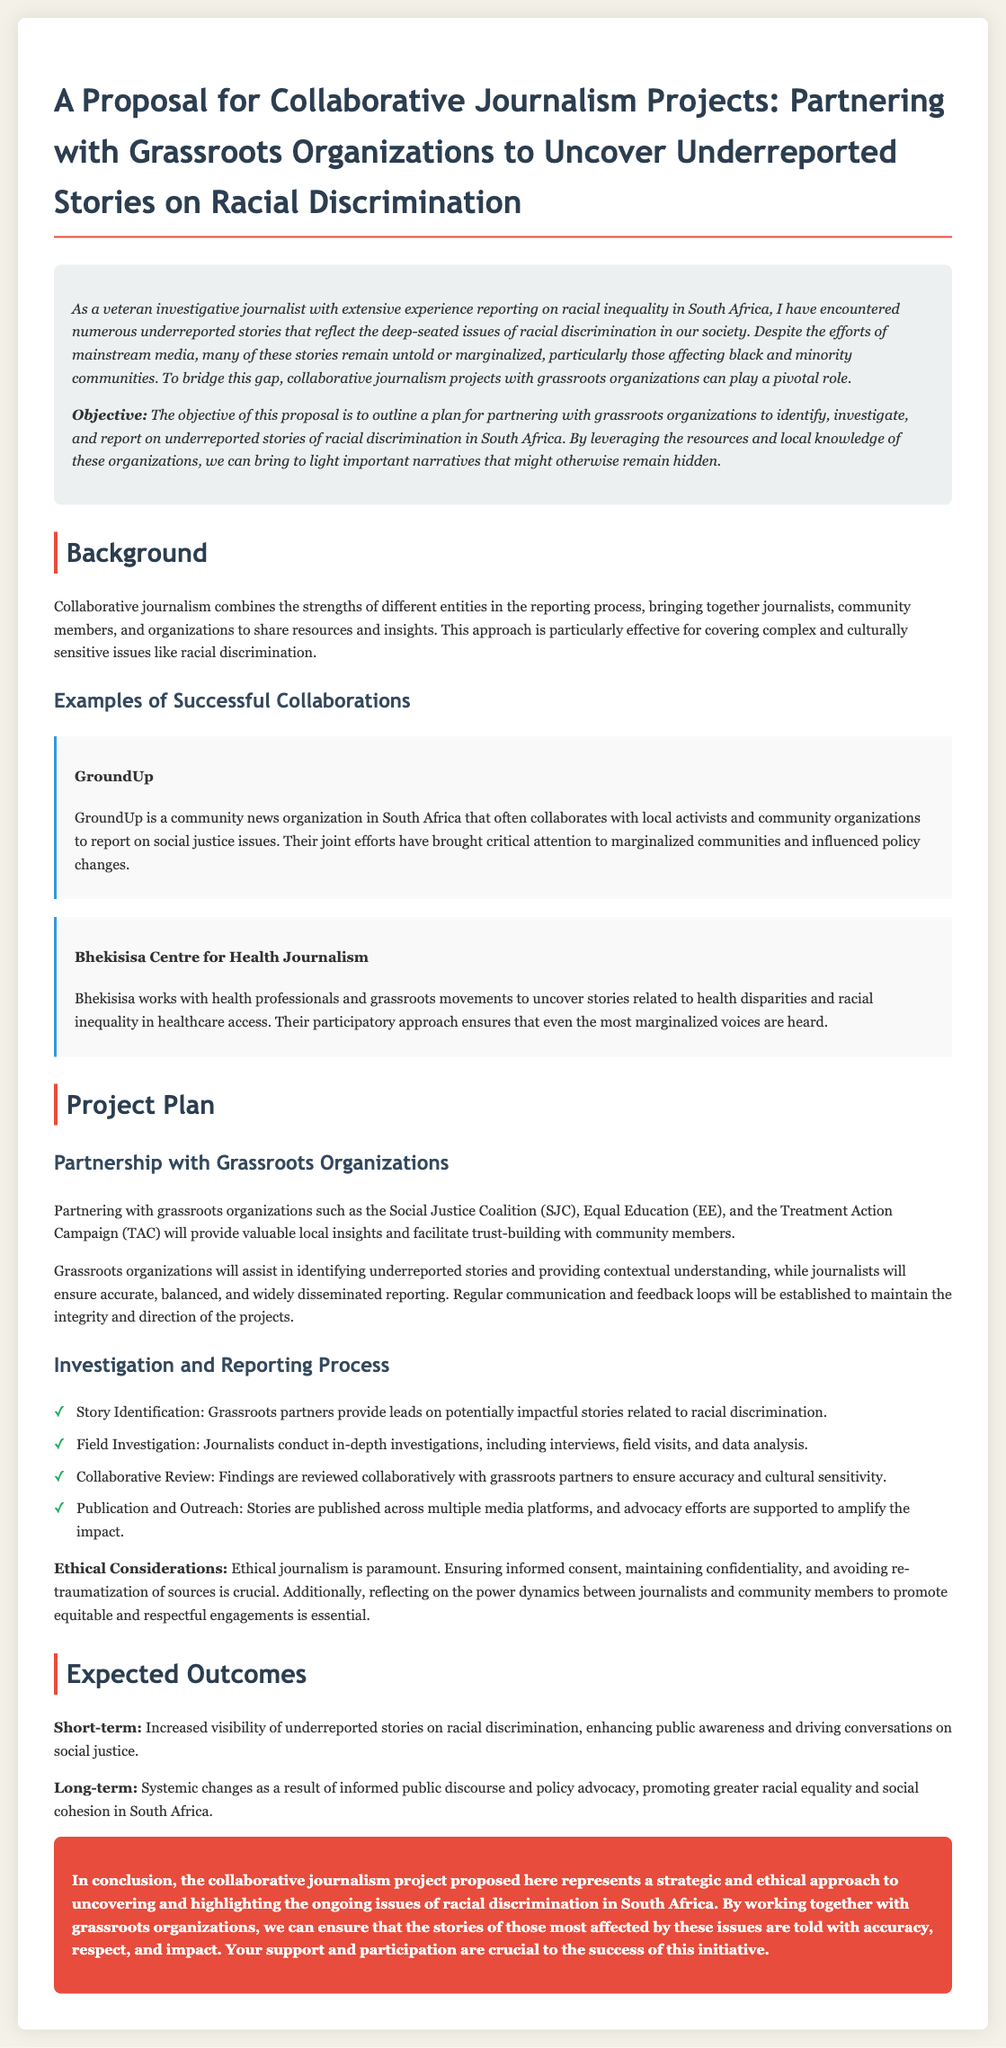What is the main objective of the proposal? The objective is to outline a plan for partnering with grassroots organizations to identify, investigate, and report on underreported stories of racial discrimination in South Africa.
Answer: Partnering with grassroots organizations Who are two examples of grassroots organizations mentioned? The document lists specific organizations that will assist in the project, which are important for providing local insights.
Answer: Social Justice Coalition, Equal Education What is the first step in the investigation and reporting process? The first step outlined involves the collaboration between grassroots partners and journalists to identify impactful stories.
Answer: Story Identification What is highlighted as a crucial ethical consideration? Ethical journalism is emphasized throughout the proposal, with particular attention to how journalists interact with community members.
Answer: Informed consent What are the expected short-term outcomes? The document details what the initiative hopes to achieve soon after implementation, particularly in public awareness.
Answer: Increased visibility of underreported stories How does the proposal describe its approach to journalism? The proposal emphasizes a collaborative method that integrates various community perspectives and journalistic resources.
Answer: Collaborative journalism What is the primary focus of the collaborative journalism project? Understanding the ultimate goal helps define the project's scope and impact on the community addressed in the document.
Answer: Racial discrimination What does the conclusion emphasize regarding the success of the initiative? The document stresses the importance of support and participation to achieve the proposed initiative's goals.
Answer: Your support and participation 